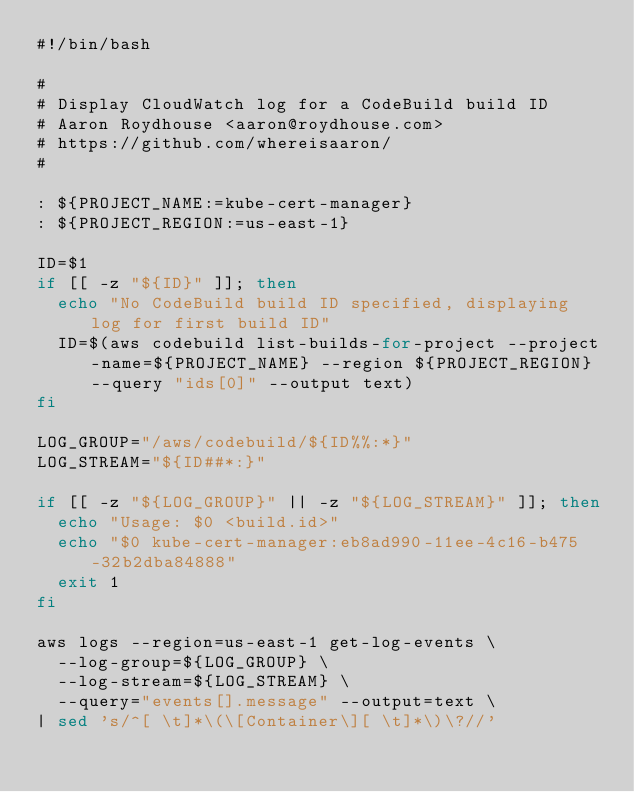<code> <loc_0><loc_0><loc_500><loc_500><_Bash_>#!/bin/bash

#
# Display CloudWatch log for a CodeBuild build ID
# Aaron Roydhouse <aaron@roydhouse.com>
# https://github.com/whereisaaron/
#

: ${PROJECT_NAME:=kube-cert-manager}
: ${PROJECT_REGION:=us-east-1}

ID=$1
if [[ -z "${ID}" ]]; then
  echo "No CodeBuild build ID specified, displaying log for first build ID"
  ID=$(aws codebuild list-builds-for-project --project-name=${PROJECT_NAME} --region ${PROJECT_REGION} --query "ids[0]" --output text)
fi

LOG_GROUP="/aws/codebuild/${ID%%:*}"
LOG_STREAM="${ID##*:}"

if [[ -z "${LOG_GROUP}" || -z "${LOG_STREAM}" ]]; then
  echo "Usage: $0 <build.id>"
  echo "$0 kube-cert-manager:eb8ad990-11ee-4c16-b475-32b2dba84888"
  exit 1
fi

aws logs --region=us-east-1 get-log-events \
  --log-group=${LOG_GROUP} \
  --log-stream=${LOG_STREAM} \
  --query="events[].message" --output=text \
| sed 's/^[ \t]*\(\[Container\][ \t]*\)\?//'
</code> 